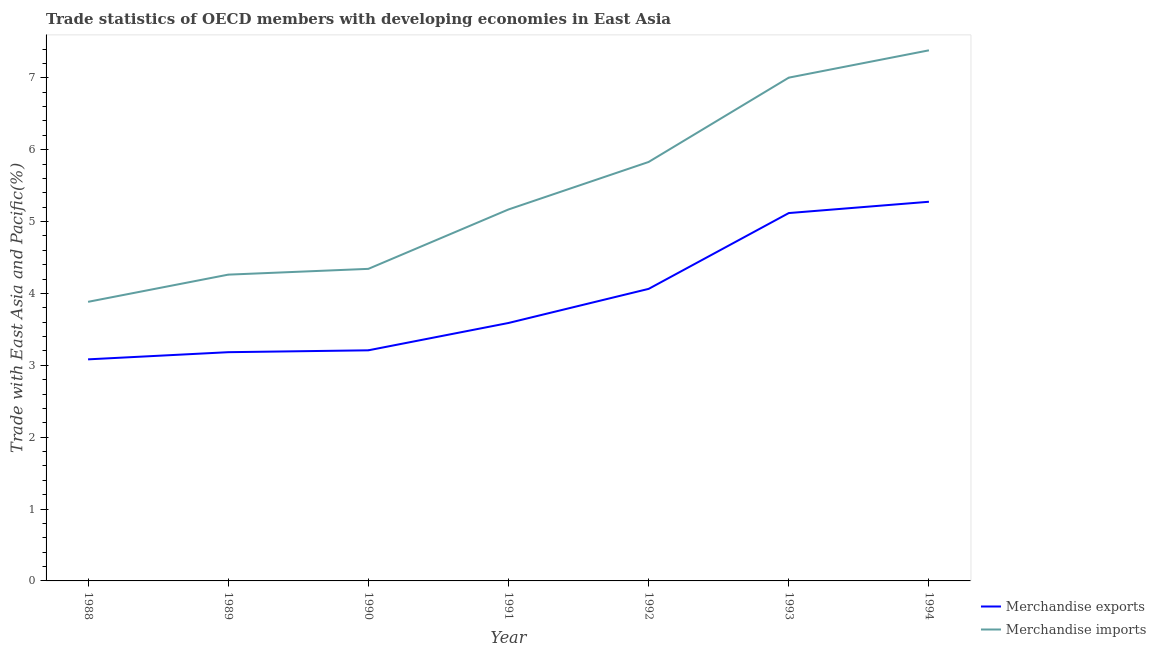What is the merchandise exports in 1992?
Make the answer very short. 4.06. Across all years, what is the maximum merchandise exports?
Your answer should be very brief. 5.28. Across all years, what is the minimum merchandise exports?
Keep it short and to the point. 3.08. What is the total merchandise exports in the graph?
Give a very brief answer. 27.52. What is the difference between the merchandise imports in 1993 and that in 1994?
Give a very brief answer. -0.38. What is the difference between the merchandise exports in 1991 and the merchandise imports in 1992?
Make the answer very short. -2.24. What is the average merchandise exports per year?
Give a very brief answer. 3.93. In the year 1993, what is the difference between the merchandise imports and merchandise exports?
Provide a short and direct response. 1.88. In how many years, is the merchandise imports greater than 6 %?
Make the answer very short. 2. What is the ratio of the merchandise imports in 1988 to that in 1991?
Offer a terse response. 0.75. What is the difference between the highest and the second highest merchandise exports?
Keep it short and to the point. 0.16. What is the difference between the highest and the lowest merchandise exports?
Provide a succinct answer. 2.19. In how many years, is the merchandise exports greater than the average merchandise exports taken over all years?
Keep it short and to the point. 3. Is the sum of the merchandise exports in 1993 and 1994 greater than the maximum merchandise imports across all years?
Offer a terse response. Yes. Is the merchandise imports strictly greater than the merchandise exports over the years?
Offer a very short reply. Yes. Is the merchandise imports strictly less than the merchandise exports over the years?
Your answer should be very brief. No. What is the difference between two consecutive major ticks on the Y-axis?
Your response must be concise. 1. Does the graph contain any zero values?
Give a very brief answer. No. How are the legend labels stacked?
Your response must be concise. Vertical. What is the title of the graph?
Keep it short and to the point. Trade statistics of OECD members with developing economies in East Asia. Does "Foreign Liabilities" appear as one of the legend labels in the graph?
Offer a very short reply. No. What is the label or title of the Y-axis?
Offer a terse response. Trade with East Asia and Pacific(%). What is the Trade with East Asia and Pacific(%) of Merchandise exports in 1988?
Offer a very short reply. 3.08. What is the Trade with East Asia and Pacific(%) in Merchandise imports in 1988?
Provide a short and direct response. 3.88. What is the Trade with East Asia and Pacific(%) of Merchandise exports in 1989?
Ensure brevity in your answer.  3.18. What is the Trade with East Asia and Pacific(%) in Merchandise imports in 1989?
Your answer should be very brief. 4.26. What is the Trade with East Asia and Pacific(%) of Merchandise exports in 1990?
Ensure brevity in your answer.  3.21. What is the Trade with East Asia and Pacific(%) in Merchandise imports in 1990?
Your answer should be compact. 4.34. What is the Trade with East Asia and Pacific(%) of Merchandise exports in 1991?
Your answer should be compact. 3.59. What is the Trade with East Asia and Pacific(%) in Merchandise imports in 1991?
Provide a short and direct response. 5.17. What is the Trade with East Asia and Pacific(%) of Merchandise exports in 1992?
Your answer should be very brief. 4.06. What is the Trade with East Asia and Pacific(%) in Merchandise imports in 1992?
Make the answer very short. 5.83. What is the Trade with East Asia and Pacific(%) of Merchandise exports in 1993?
Ensure brevity in your answer.  5.12. What is the Trade with East Asia and Pacific(%) in Merchandise imports in 1993?
Your answer should be compact. 7. What is the Trade with East Asia and Pacific(%) in Merchandise exports in 1994?
Your answer should be very brief. 5.28. What is the Trade with East Asia and Pacific(%) in Merchandise imports in 1994?
Provide a succinct answer. 7.38. Across all years, what is the maximum Trade with East Asia and Pacific(%) of Merchandise exports?
Your answer should be compact. 5.28. Across all years, what is the maximum Trade with East Asia and Pacific(%) of Merchandise imports?
Keep it short and to the point. 7.38. Across all years, what is the minimum Trade with East Asia and Pacific(%) of Merchandise exports?
Your answer should be compact. 3.08. Across all years, what is the minimum Trade with East Asia and Pacific(%) in Merchandise imports?
Provide a short and direct response. 3.88. What is the total Trade with East Asia and Pacific(%) in Merchandise exports in the graph?
Keep it short and to the point. 27.52. What is the total Trade with East Asia and Pacific(%) of Merchandise imports in the graph?
Your answer should be very brief. 37.87. What is the difference between the Trade with East Asia and Pacific(%) of Merchandise exports in 1988 and that in 1989?
Give a very brief answer. -0.1. What is the difference between the Trade with East Asia and Pacific(%) in Merchandise imports in 1988 and that in 1989?
Your response must be concise. -0.38. What is the difference between the Trade with East Asia and Pacific(%) in Merchandise exports in 1988 and that in 1990?
Offer a terse response. -0.13. What is the difference between the Trade with East Asia and Pacific(%) in Merchandise imports in 1988 and that in 1990?
Ensure brevity in your answer.  -0.46. What is the difference between the Trade with East Asia and Pacific(%) of Merchandise exports in 1988 and that in 1991?
Offer a terse response. -0.51. What is the difference between the Trade with East Asia and Pacific(%) of Merchandise imports in 1988 and that in 1991?
Make the answer very short. -1.29. What is the difference between the Trade with East Asia and Pacific(%) of Merchandise exports in 1988 and that in 1992?
Your response must be concise. -0.98. What is the difference between the Trade with East Asia and Pacific(%) in Merchandise imports in 1988 and that in 1992?
Your answer should be very brief. -1.95. What is the difference between the Trade with East Asia and Pacific(%) of Merchandise exports in 1988 and that in 1993?
Provide a short and direct response. -2.04. What is the difference between the Trade with East Asia and Pacific(%) in Merchandise imports in 1988 and that in 1993?
Ensure brevity in your answer.  -3.12. What is the difference between the Trade with East Asia and Pacific(%) of Merchandise exports in 1988 and that in 1994?
Provide a short and direct response. -2.19. What is the difference between the Trade with East Asia and Pacific(%) in Merchandise imports in 1988 and that in 1994?
Offer a very short reply. -3.5. What is the difference between the Trade with East Asia and Pacific(%) of Merchandise exports in 1989 and that in 1990?
Keep it short and to the point. -0.03. What is the difference between the Trade with East Asia and Pacific(%) of Merchandise imports in 1989 and that in 1990?
Make the answer very short. -0.08. What is the difference between the Trade with East Asia and Pacific(%) of Merchandise exports in 1989 and that in 1991?
Offer a terse response. -0.41. What is the difference between the Trade with East Asia and Pacific(%) in Merchandise imports in 1989 and that in 1991?
Ensure brevity in your answer.  -0.91. What is the difference between the Trade with East Asia and Pacific(%) of Merchandise exports in 1989 and that in 1992?
Provide a succinct answer. -0.88. What is the difference between the Trade with East Asia and Pacific(%) in Merchandise imports in 1989 and that in 1992?
Your response must be concise. -1.57. What is the difference between the Trade with East Asia and Pacific(%) in Merchandise exports in 1989 and that in 1993?
Offer a very short reply. -1.94. What is the difference between the Trade with East Asia and Pacific(%) in Merchandise imports in 1989 and that in 1993?
Keep it short and to the point. -2.74. What is the difference between the Trade with East Asia and Pacific(%) in Merchandise exports in 1989 and that in 1994?
Keep it short and to the point. -2.09. What is the difference between the Trade with East Asia and Pacific(%) in Merchandise imports in 1989 and that in 1994?
Your response must be concise. -3.12. What is the difference between the Trade with East Asia and Pacific(%) of Merchandise exports in 1990 and that in 1991?
Keep it short and to the point. -0.38. What is the difference between the Trade with East Asia and Pacific(%) in Merchandise imports in 1990 and that in 1991?
Keep it short and to the point. -0.83. What is the difference between the Trade with East Asia and Pacific(%) of Merchandise exports in 1990 and that in 1992?
Your response must be concise. -0.85. What is the difference between the Trade with East Asia and Pacific(%) in Merchandise imports in 1990 and that in 1992?
Offer a terse response. -1.49. What is the difference between the Trade with East Asia and Pacific(%) of Merchandise exports in 1990 and that in 1993?
Provide a succinct answer. -1.91. What is the difference between the Trade with East Asia and Pacific(%) of Merchandise imports in 1990 and that in 1993?
Keep it short and to the point. -2.66. What is the difference between the Trade with East Asia and Pacific(%) in Merchandise exports in 1990 and that in 1994?
Ensure brevity in your answer.  -2.07. What is the difference between the Trade with East Asia and Pacific(%) of Merchandise imports in 1990 and that in 1994?
Ensure brevity in your answer.  -3.04. What is the difference between the Trade with East Asia and Pacific(%) of Merchandise exports in 1991 and that in 1992?
Your answer should be compact. -0.47. What is the difference between the Trade with East Asia and Pacific(%) in Merchandise imports in 1991 and that in 1992?
Offer a very short reply. -0.66. What is the difference between the Trade with East Asia and Pacific(%) in Merchandise exports in 1991 and that in 1993?
Offer a very short reply. -1.53. What is the difference between the Trade with East Asia and Pacific(%) in Merchandise imports in 1991 and that in 1993?
Keep it short and to the point. -1.83. What is the difference between the Trade with East Asia and Pacific(%) of Merchandise exports in 1991 and that in 1994?
Offer a terse response. -1.69. What is the difference between the Trade with East Asia and Pacific(%) in Merchandise imports in 1991 and that in 1994?
Offer a terse response. -2.21. What is the difference between the Trade with East Asia and Pacific(%) of Merchandise exports in 1992 and that in 1993?
Offer a terse response. -1.05. What is the difference between the Trade with East Asia and Pacific(%) in Merchandise imports in 1992 and that in 1993?
Your answer should be very brief. -1.17. What is the difference between the Trade with East Asia and Pacific(%) of Merchandise exports in 1992 and that in 1994?
Your answer should be compact. -1.21. What is the difference between the Trade with East Asia and Pacific(%) in Merchandise imports in 1992 and that in 1994?
Offer a terse response. -1.55. What is the difference between the Trade with East Asia and Pacific(%) in Merchandise exports in 1993 and that in 1994?
Provide a succinct answer. -0.16. What is the difference between the Trade with East Asia and Pacific(%) in Merchandise imports in 1993 and that in 1994?
Your response must be concise. -0.38. What is the difference between the Trade with East Asia and Pacific(%) in Merchandise exports in 1988 and the Trade with East Asia and Pacific(%) in Merchandise imports in 1989?
Provide a short and direct response. -1.18. What is the difference between the Trade with East Asia and Pacific(%) of Merchandise exports in 1988 and the Trade with East Asia and Pacific(%) of Merchandise imports in 1990?
Give a very brief answer. -1.26. What is the difference between the Trade with East Asia and Pacific(%) in Merchandise exports in 1988 and the Trade with East Asia and Pacific(%) in Merchandise imports in 1991?
Provide a short and direct response. -2.09. What is the difference between the Trade with East Asia and Pacific(%) in Merchandise exports in 1988 and the Trade with East Asia and Pacific(%) in Merchandise imports in 1992?
Your answer should be very brief. -2.75. What is the difference between the Trade with East Asia and Pacific(%) of Merchandise exports in 1988 and the Trade with East Asia and Pacific(%) of Merchandise imports in 1993?
Ensure brevity in your answer.  -3.92. What is the difference between the Trade with East Asia and Pacific(%) of Merchandise exports in 1988 and the Trade with East Asia and Pacific(%) of Merchandise imports in 1994?
Give a very brief answer. -4.3. What is the difference between the Trade with East Asia and Pacific(%) of Merchandise exports in 1989 and the Trade with East Asia and Pacific(%) of Merchandise imports in 1990?
Provide a short and direct response. -1.16. What is the difference between the Trade with East Asia and Pacific(%) of Merchandise exports in 1989 and the Trade with East Asia and Pacific(%) of Merchandise imports in 1991?
Ensure brevity in your answer.  -1.99. What is the difference between the Trade with East Asia and Pacific(%) of Merchandise exports in 1989 and the Trade with East Asia and Pacific(%) of Merchandise imports in 1992?
Give a very brief answer. -2.65. What is the difference between the Trade with East Asia and Pacific(%) of Merchandise exports in 1989 and the Trade with East Asia and Pacific(%) of Merchandise imports in 1993?
Keep it short and to the point. -3.82. What is the difference between the Trade with East Asia and Pacific(%) in Merchandise exports in 1990 and the Trade with East Asia and Pacific(%) in Merchandise imports in 1991?
Offer a terse response. -1.96. What is the difference between the Trade with East Asia and Pacific(%) of Merchandise exports in 1990 and the Trade with East Asia and Pacific(%) of Merchandise imports in 1992?
Ensure brevity in your answer.  -2.62. What is the difference between the Trade with East Asia and Pacific(%) of Merchandise exports in 1990 and the Trade with East Asia and Pacific(%) of Merchandise imports in 1993?
Keep it short and to the point. -3.79. What is the difference between the Trade with East Asia and Pacific(%) of Merchandise exports in 1990 and the Trade with East Asia and Pacific(%) of Merchandise imports in 1994?
Your answer should be very brief. -4.17. What is the difference between the Trade with East Asia and Pacific(%) in Merchandise exports in 1991 and the Trade with East Asia and Pacific(%) in Merchandise imports in 1992?
Make the answer very short. -2.24. What is the difference between the Trade with East Asia and Pacific(%) of Merchandise exports in 1991 and the Trade with East Asia and Pacific(%) of Merchandise imports in 1993?
Provide a succinct answer. -3.41. What is the difference between the Trade with East Asia and Pacific(%) in Merchandise exports in 1991 and the Trade with East Asia and Pacific(%) in Merchandise imports in 1994?
Your answer should be very brief. -3.79. What is the difference between the Trade with East Asia and Pacific(%) in Merchandise exports in 1992 and the Trade with East Asia and Pacific(%) in Merchandise imports in 1993?
Ensure brevity in your answer.  -2.94. What is the difference between the Trade with East Asia and Pacific(%) in Merchandise exports in 1992 and the Trade with East Asia and Pacific(%) in Merchandise imports in 1994?
Ensure brevity in your answer.  -3.32. What is the difference between the Trade with East Asia and Pacific(%) in Merchandise exports in 1993 and the Trade with East Asia and Pacific(%) in Merchandise imports in 1994?
Your answer should be very brief. -2.26. What is the average Trade with East Asia and Pacific(%) in Merchandise exports per year?
Your response must be concise. 3.93. What is the average Trade with East Asia and Pacific(%) in Merchandise imports per year?
Offer a very short reply. 5.41. In the year 1988, what is the difference between the Trade with East Asia and Pacific(%) of Merchandise exports and Trade with East Asia and Pacific(%) of Merchandise imports?
Your response must be concise. -0.8. In the year 1989, what is the difference between the Trade with East Asia and Pacific(%) of Merchandise exports and Trade with East Asia and Pacific(%) of Merchandise imports?
Your response must be concise. -1.08. In the year 1990, what is the difference between the Trade with East Asia and Pacific(%) of Merchandise exports and Trade with East Asia and Pacific(%) of Merchandise imports?
Give a very brief answer. -1.13. In the year 1991, what is the difference between the Trade with East Asia and Pacific(%) of Merchandise exports and Trade with East Asia and Pacific(%) of Merchandise imports?
Give a very brief answer. -1.58. In the year 1992, what is the difference between the Trade with East Asia and Pacific(%) of Merchandise exports and Trade with East Asia and Pacific(%) of Merchandise imports?
Provide a short and direct response. -1.77. In the year 1993, what is the difference between the Trade with East Asia and Pacific(%) in Merchandise exports and Trade with East Asia and Pacific(%) in Merchandise imports?
Your answer should be compact. -1.88. In the year 1994, what is the difference between the Trade with East Asia and Pacific(%) in Merchandise exports and Trade with East Asia and Pacific(%) in Merchandise imports?
Your answer should be compact. -2.11. What is the ratio of the Trade with East Asia and Pacific(%) in Merchandise exports in 1988 to that in 1989?
Give a very brief answer. 0.97. What is the ratio of the Trade with East Asia and Pacific(%) in Merchandise imports in 1988 to that in 1989?
Offer a very short reply. 0.91. What is the ratio of the Trade with East Asia and Pacific(%) of Merchandise exports in 1988 to that in 1990?
Your answer should be compact. 0.96. What is the ratio of the Trade with East Asia and Pacific(%) of Merchandise imports in 1988 to that in 1990?
Provide a short and direct response. 0.89. What is the ratio of the Trade with East Asia and Pacific(%) of Merchandise exports in 1988 to that in 1991?
Your answer should be compact. 0.86. What is the ratio of the Trade with East Asia and Pacific(%) in Merchandise imports in 1988 to that in 1991?
Your answer should be compact. 0.75. What is the ratio of the Trade with East Asia and Pacific(%) of Merchandise exports in 1988 to that in 1992?
Ensure brevity in your answer.  0.76. What is the ratio of the Trade with East Asia and Pacific(%) in Merchandise imports in 1988 to that in 1992?
Your answer should be compact. 0.67. What is the ratio of the Trade with East Asia and Pacific(%) of Merchandise exports in 1988 to that in 1993?
Keep it short and to the point. 0.6. What is the ratio of the Trade with East Asia and Pacific(%) in Merchandise imports in 1988 to that in 1993?
Make the answer very short. 0.55. What is the ratio of the Trade with East Asia and Pacific(%) of Merchandise exports in 1988 to that in 1994?
Provide a succinct answer. 0.58. What is the ratio of the Trade with East Asia and Pacific(%) in Merchandise imports in 1988 to that in 1994?
Keep it short and to the point. 0.53. What is the ratio of the Trade with East Asia and Pacific(%) of Merchandise exports in 1989 to that in 1990?
Provide a short and direct response. 0.99. What is the ratio of the Trade with East Asia and Pacific(%) of Merchandise imports in 1989 to that in 1990?
Keep it short and to the point. 0.98. What is the ratio of the Trade with East Asia and Pacific(%) in Merchandise exports in 1989 to that in 1991?
Provide a short and direct response. 0.89. What is the ratio of the Trade with East Asia and Pacific(%) in Merchandise imports in 1989 to that in 1991?
Make the answer very short. 0.82. What is the ratio of the Trade with East Asia and Pacific(%) in Merchandise exports in 1989 to that in 1992?
Provide a succinct answer. 0.78. What is the ratio of the Trade with East Asia and Pacific(%) of Merchandise imports in 1989 to that in 1992?
Your answer should be very brief. 0.73. What is the ratio of the Trade with East Asia and Pacific(%) of Merchandise exports in 1989 to that in 1993?
Give a very brief answer. 0.62. What is the ratio of the Trade with East Asia and Pacific(%) in Merchandise imports in 1989 to that in 1993?
Your answer should be very brief. 0.61. What is the ratio of the Trade with East Asia and Pacific(%) of Merchandise exports in 1989 to that in 1994?
Ensure brevity in your answer.  0.6. What is the ratio of the Trade with East Asia and Pacific(%) of Merchandise imports in 1989 to that in 1994?
Provide a short and direct response. 0.58. What is the ratio of the Trade with East Asia and Pacific(%) of Merchandise exports in 1990 to that in 1991?
Provide a succinct answer. 0.89. What is the ratio of the Trade with East Asia and Pacific(%) of Merchandise imports in 1990 to that in 1991?
Your response must be concise. 0.84. What is the ratio of the Trade with East Asia and Pacific(%) in Merchandise exports in 1990 to that in 1992?
Make the answer very short. 0.79. What is the ratio of the Trade with East Asia and Pacific(%) in Merchandise imports in 1990 to that in 1992?
Your answer should be very brief. 0.74. What is the ratio of the Trade with East Asia and Pacific(%) in Merchandise exports in 1990 to that in 1993?
Give a very brief answer. 0.63. What is the ratio of the Trade with East Asia and Pacific(%) in Merchandise imports in 1990 to that in 1993?
Your answer should be very brief. 0.62. What is the ratio of the Trade with East Asia and Pacific(%) of Merchandise exports in 1990 to that in 1994?
Ensure brevity in your answer.  0.61. What is the ratio of the Trade with East Asia and Pacific(%) in Merchandise imports in 1990 to that in 1994?
Your answer should be compact. 0.59. What is the ratio of the Trade with East Asia and Pacific(%) of Merchandise exports in 1991 to that in 1992?
Make the answer very short. 0.88. What is the ratio of the Trade with East Asia and Pacific(%) in Merchandise imports in 1991 to that in 1992?
Your response must be concise. 0.89. What is the ratio of the Trade with East Asia and Pacific(%) of Merchandise exports in 1991 to that in 1993?
Keep it short and to the point. 0.7. What is the ratio of the Trade with East Asia and Pacific(%) of Merchandise imports in 1991 to that in 1993?
Offer a terse response. 0.74. What is the ratio of the Trade with East Asia and Pacific(%) of Merchandise exports in 1991 to that in 1994?
Offer a terse response. 0.68. What is the ratio of the Trade with East Asia and Pacific(%) in Merchandise imports in 1991 to that in 1994?
Your answer should be compact. 0.7. What is the ratio of the Trade with East Asia and Pacific(%) in Merchandise exports in 1992 to that in 1993?
Your response must be concise. 0.79. What is the ratio of the Trade with East Asia and Pacific(%) in Merchandise imports in 1992 to that in 1993?
Keep it short and to the point. 0.83. What is the ratio of the Trade with East Asia and Pacific(%) of Merchandise exports in 1992 to that in 1994?
Offer a terse response. 0.77. What is the ratio of the Trade with East Asia and Pacific(%) of Merchandise imports in 1992 to that in 1994?
Your answer should be very brief. 0.79. What is the ratio of the Trade with East Asia and Pacific(%) of Merchandise exports in 1993 to that in 1994?
Make the answer very short. 0.97. What is the ratio of the Trade with East Asia and Pacific(%) of Merchandise imports in 1993 to that in 1994?
Provide a succinct answer. 0.95. What is the difference between the highest and the second highest Trade with East Asia and Pacific(%) in Merchandise exports?
Give a very brief answer. 0.16. What is the difference between the highest and the second highest Trade with East Asia and Pacific(%) in Merchandise imports?
Ensure brevity in your answer.  0.38. What is the difference between the highest and the lowest Trade with East Asia and Pacific(%) of Merchandise exports?
Offer a very short reply. 2.19. What is the difference between the highest and the lowest Trade with East Asia and Pacific(%) in Merchandise imports?
Keep it short and to the point. 3.5. 